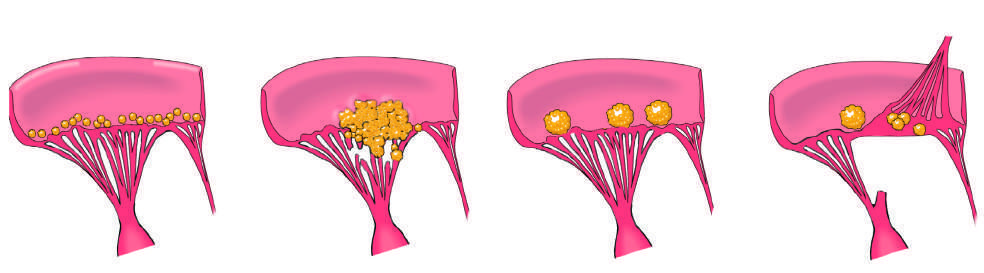does one cusp manifest with small - to medium-sized, bland, nondestructive vegetations at the line of valve closure?
Answer the question using a single word or phrase. No 